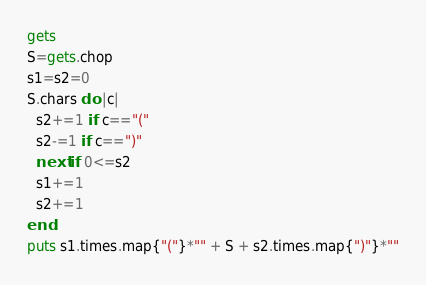<code> <loc_0><loc_0><loc_500><loc_500><_Ruby_>gets
S=gets.chop
s1=s2=0
S.chars do |c|
  s2+=1 if c=="("
  s2-=1 if c==")"
  next if 0<=s2
  s1+=1
  s2+=1
end
puts s1.times.map{"("}*"" + S + s2.times.map{")"}*""
</code> 